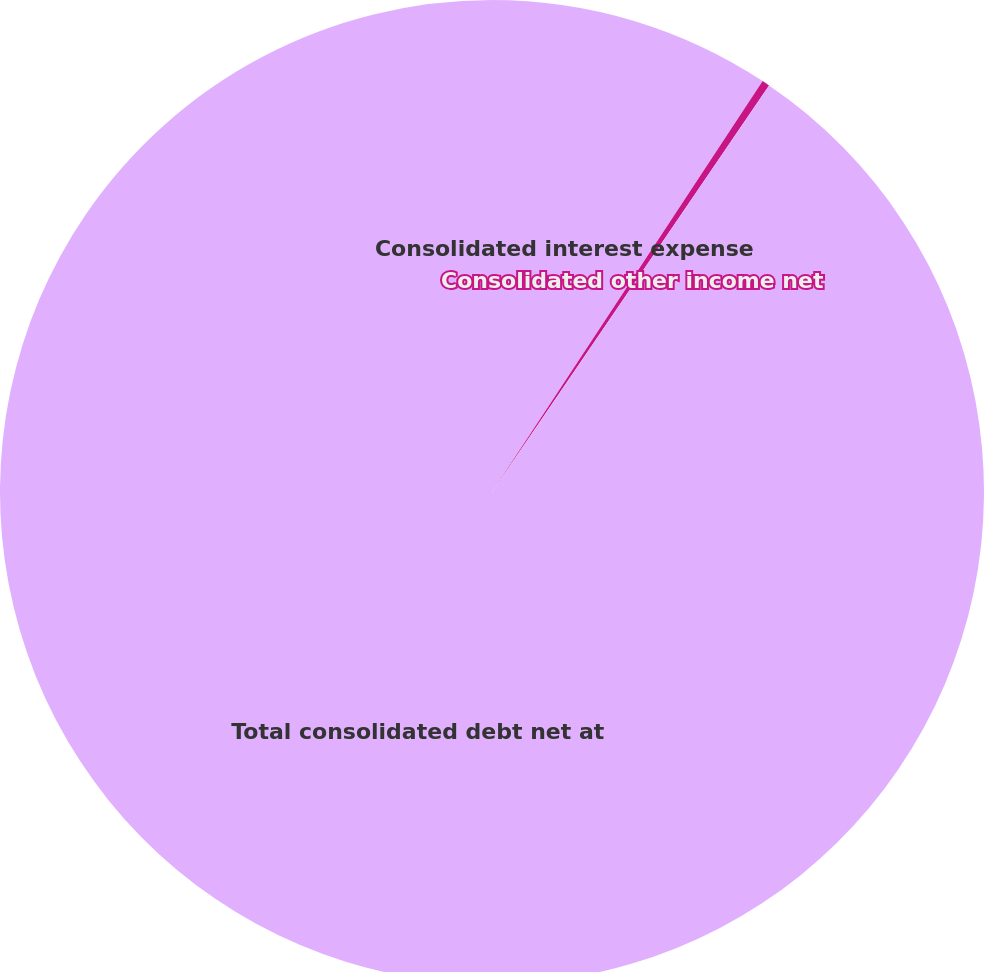<chart> <loc_0><loc_0><loc_500><loc_500><pie_chart><fcel>Consolidated interest expense<fcel>Consolidated other income net<fcel>Total consolidated debt net at<nl><fcel>9.27%<fcel>0.25%<fcel>90.48%<nl></chart> 